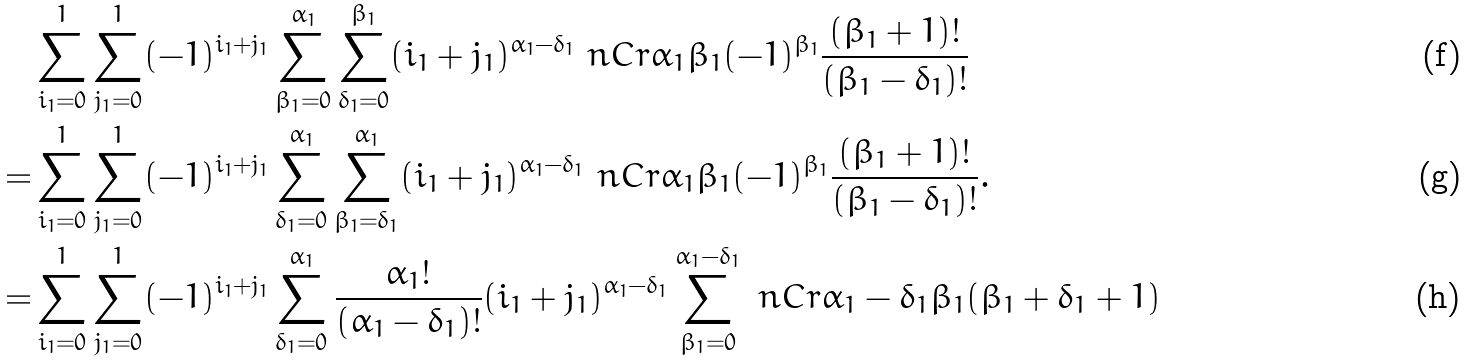<formula> <loc_0><loc_0><loc_500><loc_500>& \sum _ { i _ { 1 } = 0 } ^ { 1 } \sum _ { j _ { 1 } = 0 } ^ { 1 } ( - 1 ) ^ { i _ { 1 } + j _ { 1 } } \sum _ { \beta _ { 1 } = 0 } ^ { \alpha _ { 1 } } \sum _ { \delta _ { 1 } = 0 } ^ { \beta _ { 1 } } ( i _ { 1 } + j _ { 1 } ) ^ { \alpha _ { 1 } - \delta _ { 1 } } \ n C r { \alpha _ { 1 } } { \beta _ { 1 } } ( - 1 ) ^ { \beta _ { 1 } } \frac { ( \beta _ { 1 } + 1 ) ! } { ( \beta _ { 1 } - \delta _ { 1 } ) ! } \\ = & \sum _ { i _ { 1 } = 0 } ^ { 1 } \sum _ { j _ { 1 } = 0 } ^ { 1 } ( - 1 ) ^ { i _ { 1 } + j _ { 1 } } \sum _ { \delta _ { 1 } = 0 } ^ { \alpha _ { 1 } } \sum _ { \beta _ { 1 } = \delta _ { 1 } } ^ { \alpha _ { 1 } } ( i _ { 1 } + j _ { 1 } ) ^ { \alpha _ { 1 } - \delta _ { 1 } } \ n C r { \alpha _ { 1 } } { \beta _ { 1 } } ( - 1 ) ^ { \beta _ { 1 } } \frac { ( \beta _ { 1 } + 1 ) ! } { ( \beta _ { 1 } - \delta _ { 1 } ) ! } . \\ = & \sum _ { i _ { 1 } = 0 } ^ { 1 } \sum _ { j _ { 1 } = 0 } ^ { 1 } ( - 1 ) ^ { i _ { 1 } + j _ { 1 } } \sum _ { \delta _ { 1 } = 0 } ^ { \alpha _ { 1 } } \frac { \alpha _ { 1 } ! } { ( \alpha _ { 1 } - \delta _ { 1 } ) ! } ( i _ { 1 } + j _ { 1 } ) ^ { \alpha _ { 1 } - \delta _ { 1 } } \sum _ { \beta _ { 1 } = 0 } ^ { \alpha _ { 1 } - \delta _ { 1 } } \ n C r { \alpha _ { 1 } - \delta _ { 1 } } { \beta _ { 1 } } ( \beta _ { 1 } + \delta _ { 1 } + 1 )</formula> 